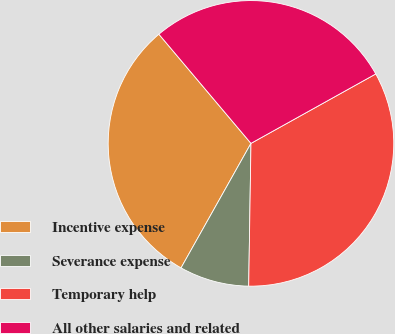Convert chart to OTSL. <chart><loc_0><loc_0><loc_500><loc_500><pie_chart><fcel>Incentive expense<fcel>Severance expense<fcel>Temporary help<fcel>All other salaries and related<nl><fcel>30.7%<fcel>7.89%<fcel>33.33%<fcel>28.07%<nl></chart> 